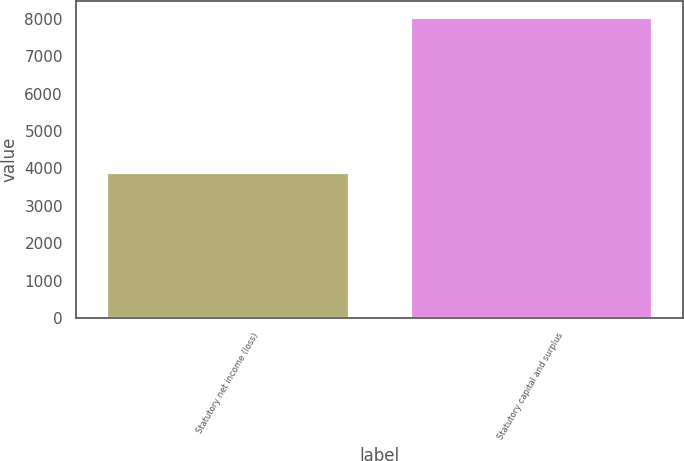Convert chart to OTSL. <chart><loc_0><loc_0><loc_500><loc_500><bar_chart><fcel>Statutory net income (loss)<fcel>Statutory capital and surplus<nl><fcel>3911<fcel>8059<nl></chart> 